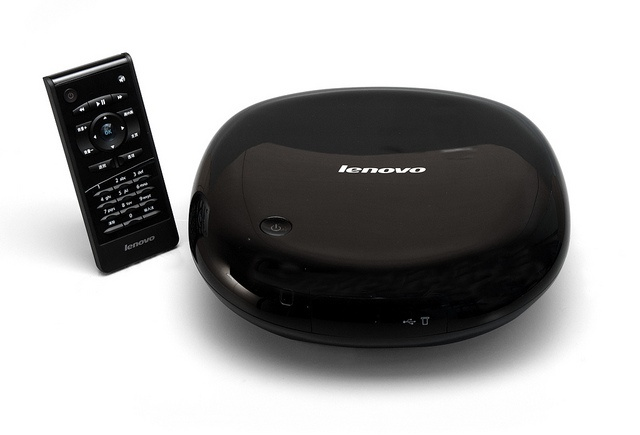Describe the objects in this image and their specific colors. I can see a remote in white, black, gray, and darkgray tones in this image. 